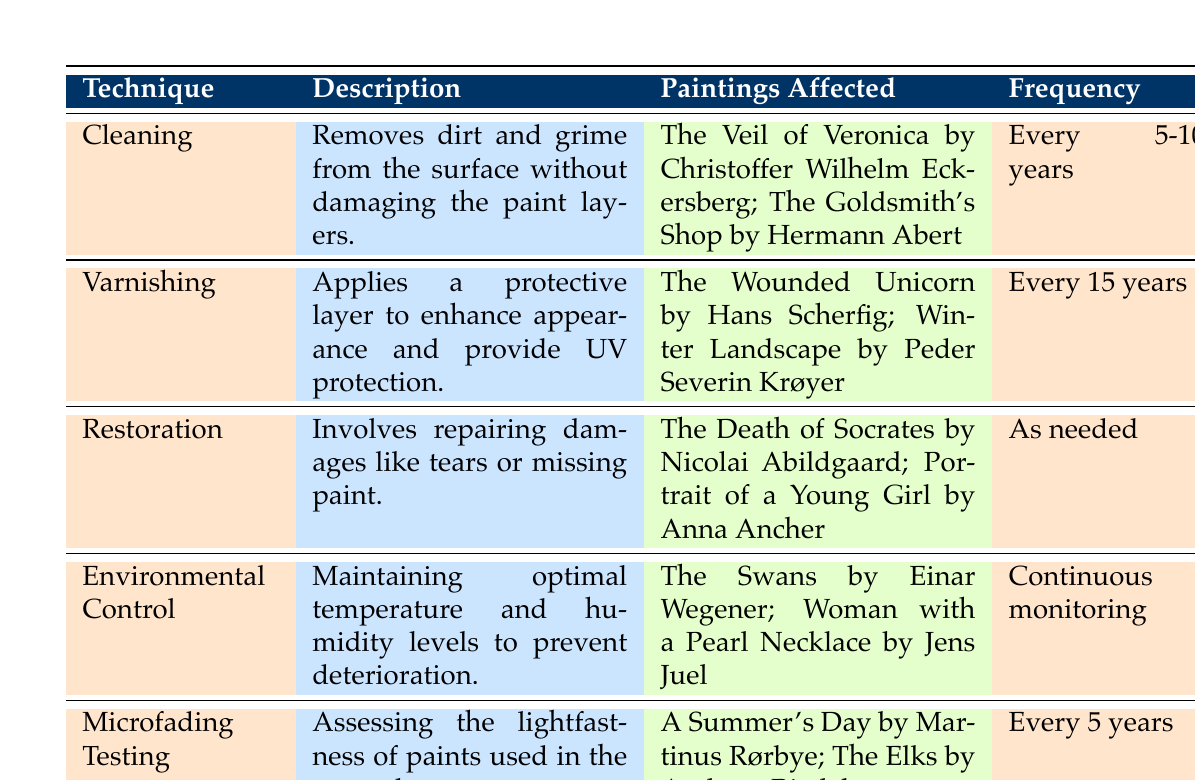What technique is used for removing dirt and grime from the surface? The table lists "Cleaning" as the technique specifically for removing dirt and grime from the surface without damaging the paint layers.
Answer: Cleaning Which painting is affected by the varnishing technique? According to the table, "The Wounded Unicorn by Hans Scherfig" is one of the paintings affected by the varnishing technique.
Answer: The Wounded Unicorn by Hans Scherfig What is the frequency of performing restoration techniques? The table indicates that restoration is performed "As needed," which means it does not have a fixed frequency like other techniques.
Answer: As needed Is the frequency for microfading testing every five years? A quick look at the table shows that the frequency for microfading testing is listed as "Every 5 years," confirming that this statement is true.
Answer: Yes How many paintings are affected by the environmental control technique? By reviewing the table, we can see that two paintings are listed under the environmental control technique: "The Swans by Einar Wegener" and "Woman with a Pearl Necklace by Jens Juel," equating to a total of 2 paintings.
Answer: 2 Which technique has a frequency of continuous monitoring? The table specifies that the environmental control technique has "Continuous monitoring" as its frequency, indicating it requires ongoing attention.
Answer: Environmental Control What is the average frequency of cleaning and microfading testing techniques combined? For cleaning, the frequency is every 5-10 years, and for microfading testing, it's every 5 years. If we take an average value, assuming 7.5 years for cleaning: (7.5 + 5) / 2 = 6.25 years. Therefore, the average frequency is approximately 6.25 years.
Answer: 6.25 years Are there any techniques that use synthetic agents? The Varnishing technique uses "Synthetic varnishes," indicating there are synthetic agents employed in art preservation techniques according to the data in the table.
Answer: Yes Which technique involves repairing damages? The table clearly lists "Restoration" as the technique specifically focused on repairing damages like tears or missing paint.
Answer: Restoration 